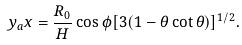<formula> <loc_0><loc_0><loc_500><loc_500>y _ { a } x = \frac { R _ { 0 } } { H } \cos \phi [ 3 ( 1 - \theta \cot \theta ) ] ^ { 1 / 2 } .</formula> 